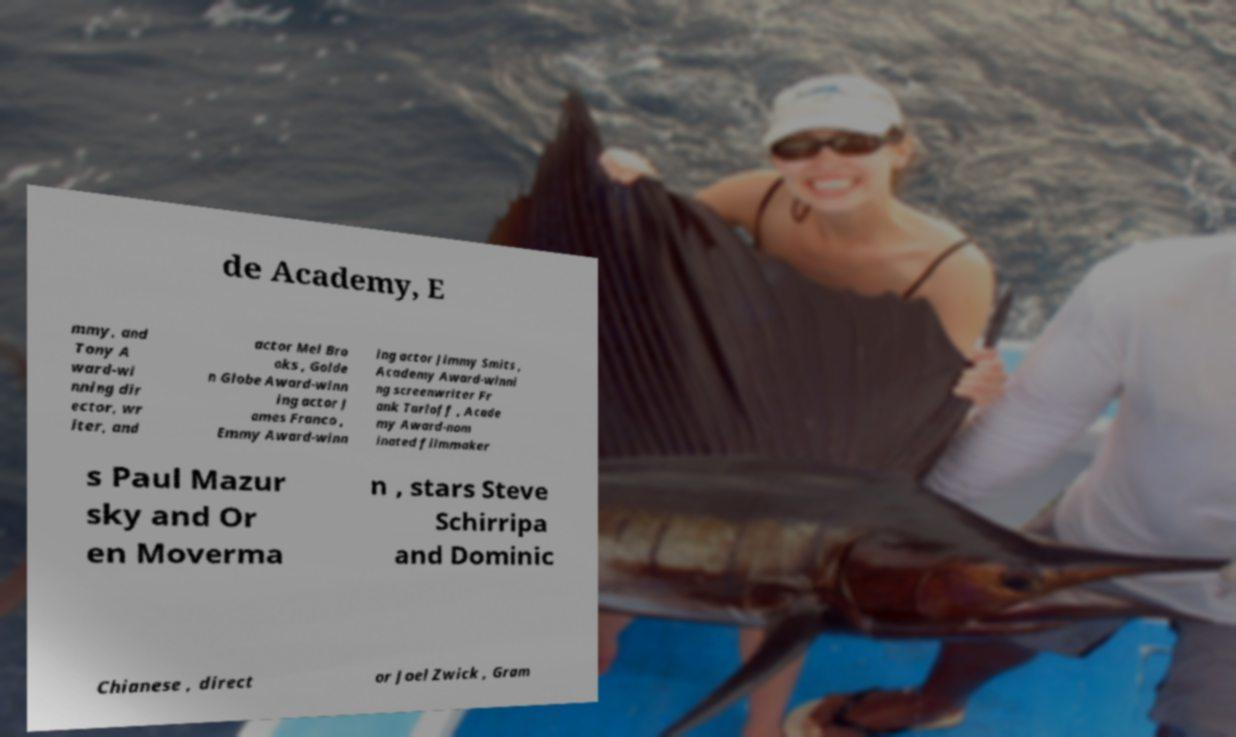There's text embedded in this image that I need extracted. Can you transcribe it verbatim? de Academy, E mmy, and Tony A ward-wi nning dir ector, wr iter, and actor Mel Bro oks , Golde n Globe Award-winn ing actor J ames Franco , Emmy Award-winn ing actor Jimmy Smits , Academy Award-winni ng screenwriter Fr ank Tarloff , Acade my Award-nom inated filmmaker s Paul Mazur sky and Or en Moverma n , stars Steve Schirripa and Dominic Chianese , direct or Joel Zwick , Gram 